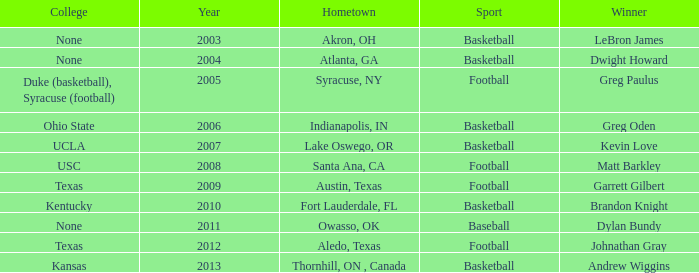What is the total number of Year, when Winner is "Johnathan Gray"? 1.0. 